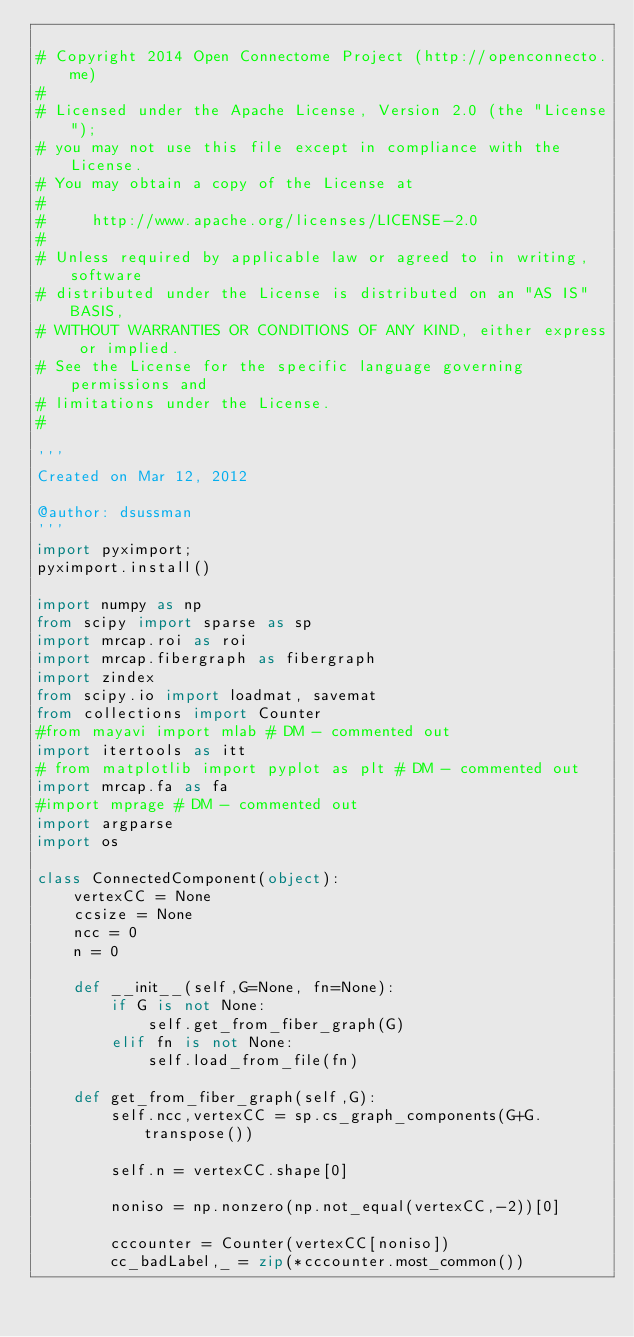<code> <loc_0><loc_0><loc_500><loc_500><_Python_>
# Copyright 2014 Open Connectome Project (http://openconnecto.me)
#
# Licensed under the Apache License, Version 2.0 (the "License");
# you may not use this file except in compliance with the License.
# You may obtain a copy of the License at
#
#     http://www.apache.org/licenses/LICENSE-2.0
#
# Unless required by applicable law or agreed to in writing, software
# distributed under the License is distributed on an "AS IS" BASIS,
# WITHOUT WARRANTIES OR CONDITIONS OF ANY KIND, either express or implied.
# See the License for the specific language governing permissions and
# limitations under the License.
#

'''
Created on Mar 12, 2012

@author: dsussman
'''
import pyximport;
pyximport.install()

import numpy as np
from scipy import sparse as sp
import mrcap.roi as roi
import mrcap.fibergraph as fibergraph
import zindex
from scipy.io import loadmat, savemat
from collections import Counter
#from mayavi import mlab # DM - commented out
import itertools as itt
# from matplotlib import pyplot as plt # DM - commented out
import mrcap.fa as fa
#import mprage # DM - commented out
import argparse
import os

class ConnectedComponent(object):
    vertexCC = None
    ccsize = None
    ncc = 0
    n = 0

    def __init__(self,G=None, fn=None):
        if G is not None:
            self.get_from_fiber_graph(G)
        elif fn is not None:
            self.load_from_file(fn)

    def get_from_fiber_graph(self,G):
        self.ncc,vertexCC = sp.cs_graph_components(G+G.transpose())

        self.n = vertexCC.shape[0]

        noniso = np.nonzero(np.not_equal(vertexCC,-2))[0]

        cccounter = Counter(vertexCC[noniso])
        cc_badLabel,_ = zip(*cccounter.most_common())</code> 